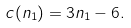Convert formula to latex. <formula><loc_0><loc_0><loc_500><loc_500>c ( n _ { 1 } ) = 3 n _ { 1 } - 6 .</formula> 